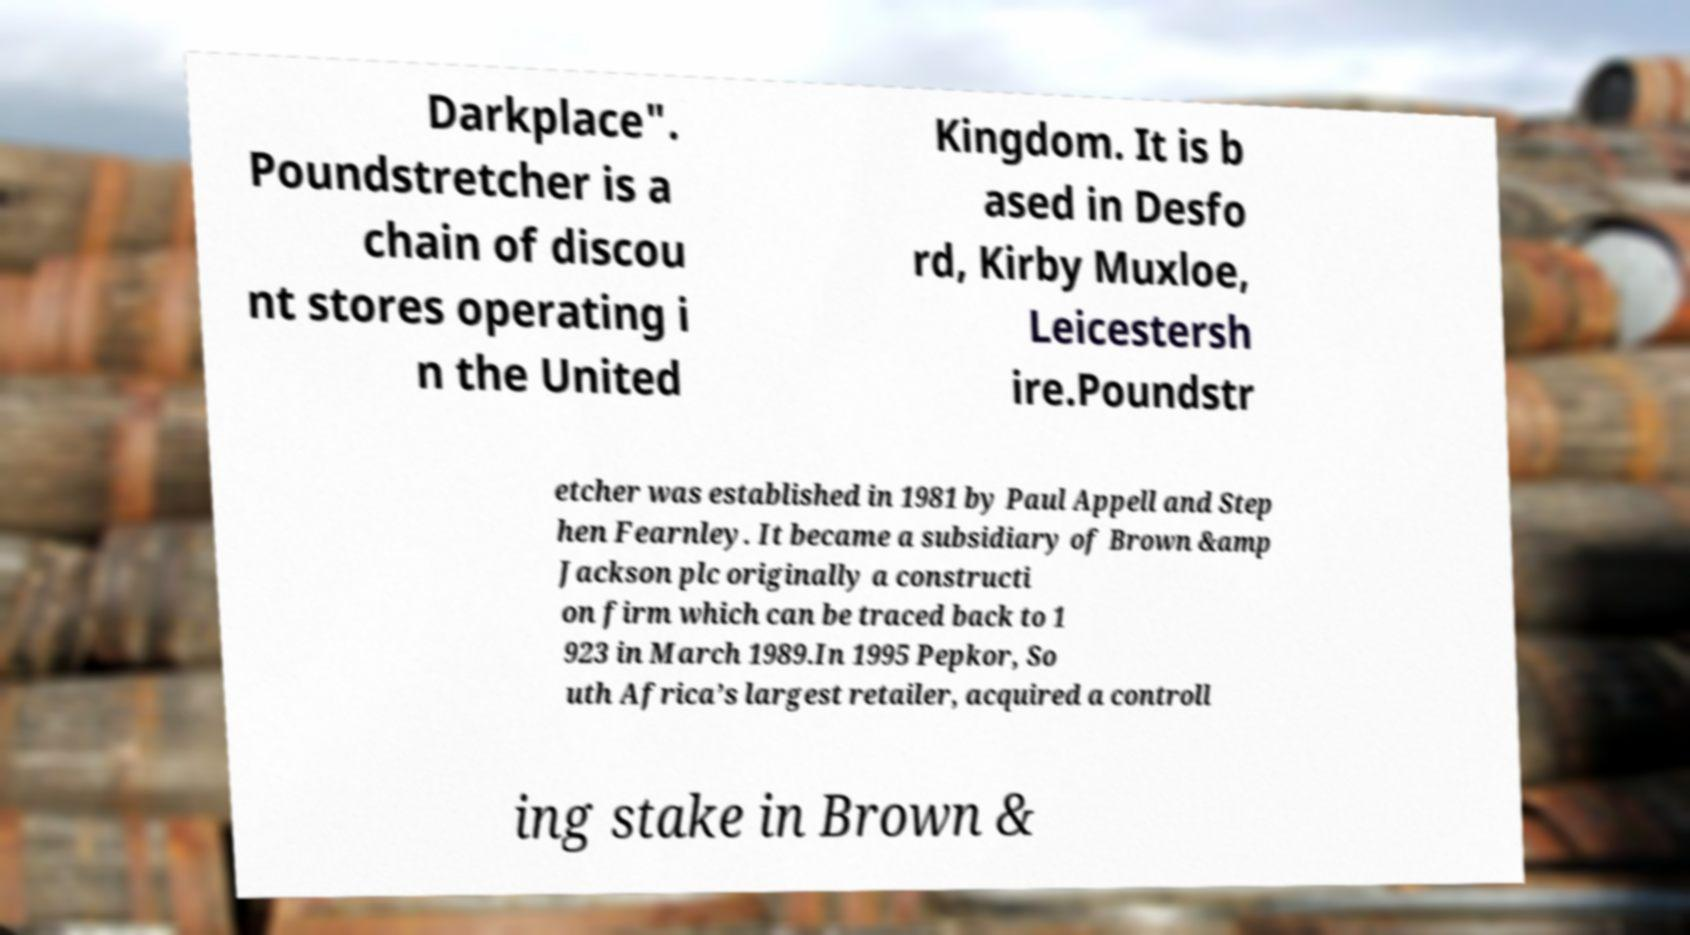Could you assist in decoding the text presented in this image and type it out clearly? Darkplace". Poundstretcher is a chain of discou nt stores operating i n the United Kingdom. It is b ased in Desfo rd, Kirby Muxloe, Leicestersh ire.Poundstr etcher was established in 1981 by Paul Appell and Step hen Fearnley. It became a subsidiary of Brown &amp Jackson plc originally a constructi on firm which can be traced back to 1 923 in March 1989.In 1995 Pepkor, So uth Africa’s largest retailer, acquired a controll ing stake in Brown & 